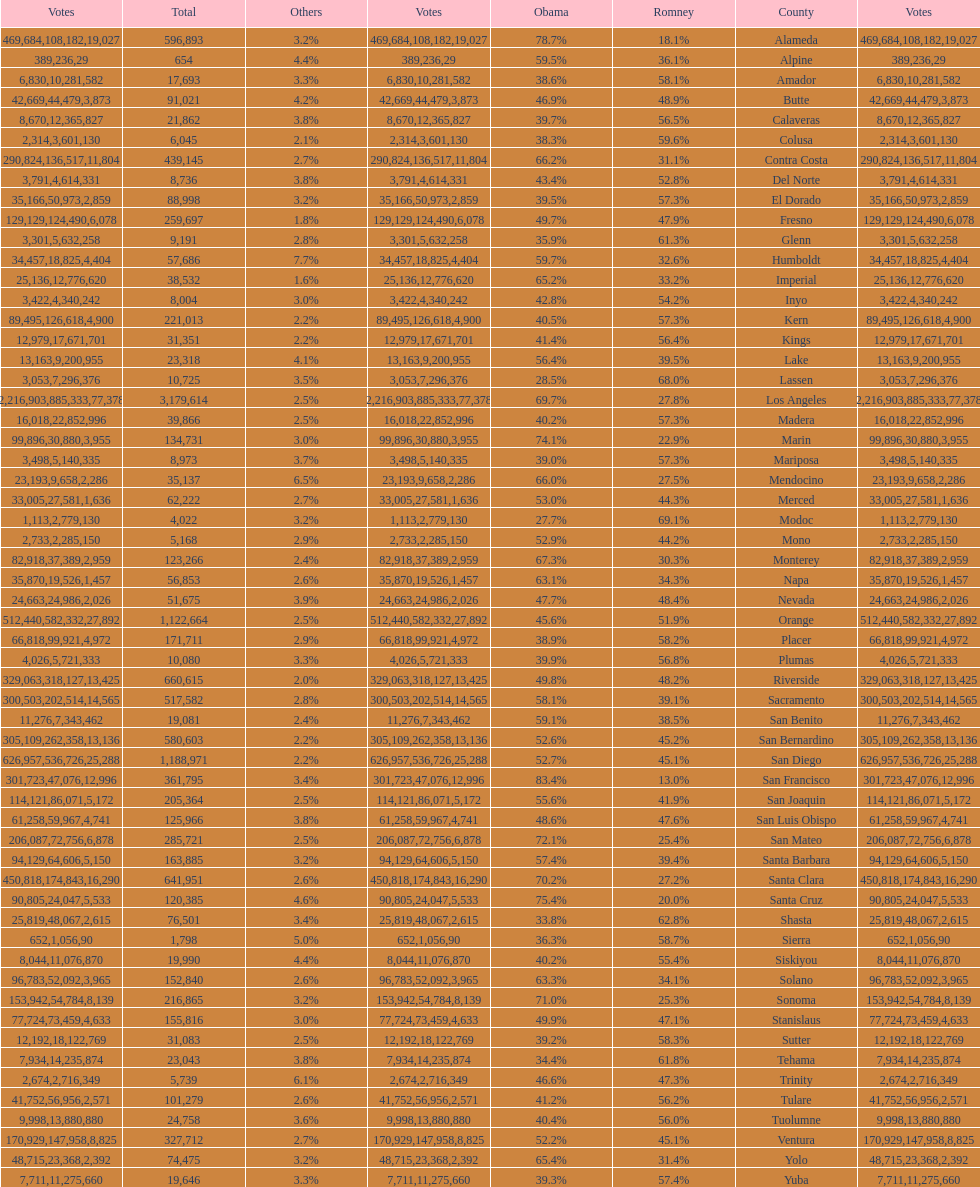How many counties had at least 75% of the votes for obama? 3. 